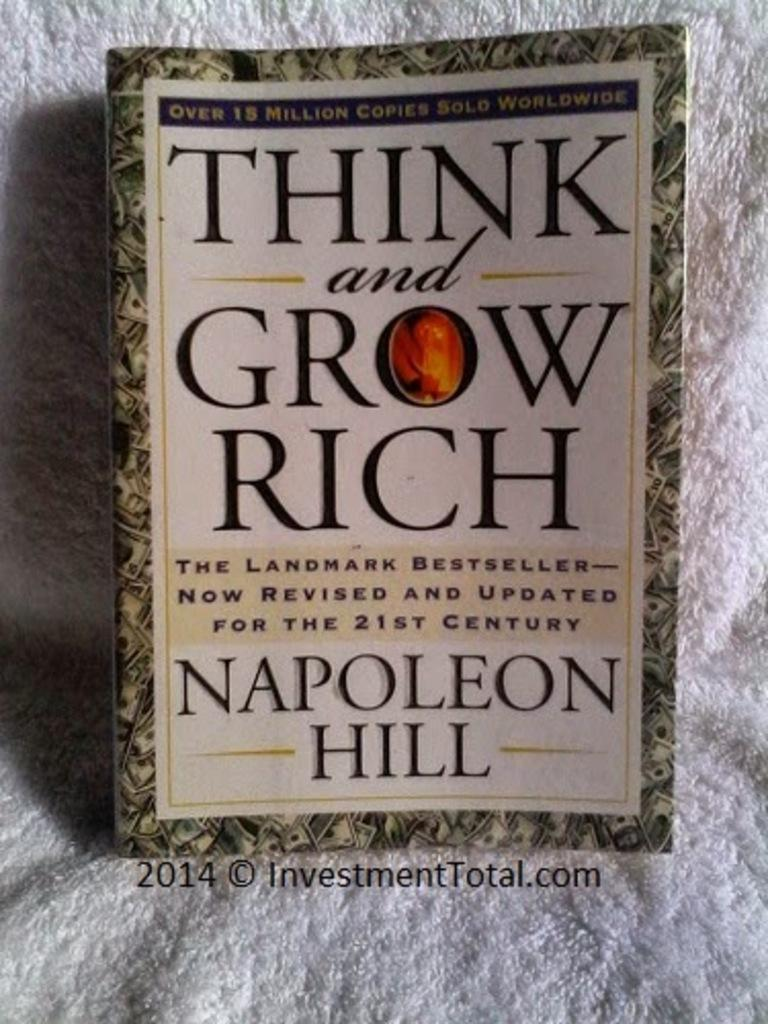<image>
Give a short and clear explanation of the subsequent image. A book entitled Think and Grow Rich, a bestseller, was written by Napoleon Hill. 